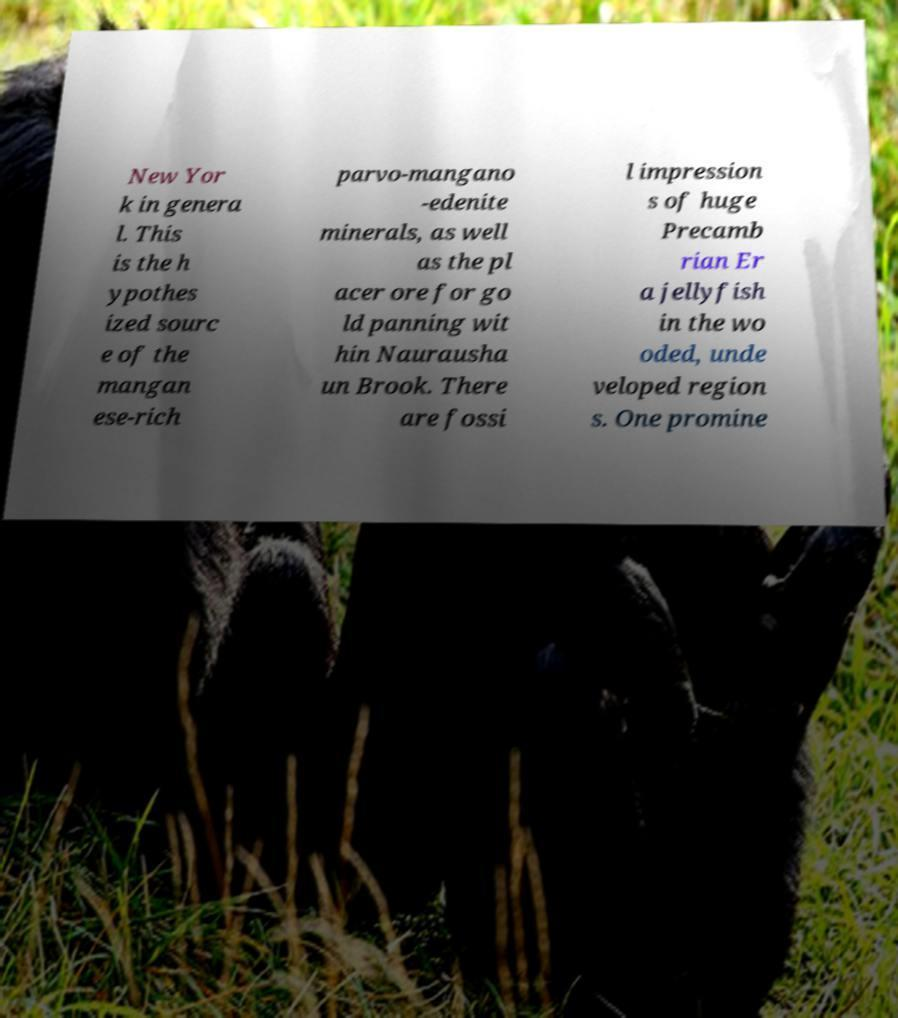What messages or text are displayed in this image? I need them in a readable, typed format. New Yor k in genera l. This is the h ypothes ized sourc e of the mangan ese-rich parvo-mangano -edenite minerals, as well as the pl acer ore for go ld panning wit hin Naurausha un Brook. There are fossi l impression s of huge Precamb rian Er a jellyfish in the wo oded, unde veloped region s. One promine 